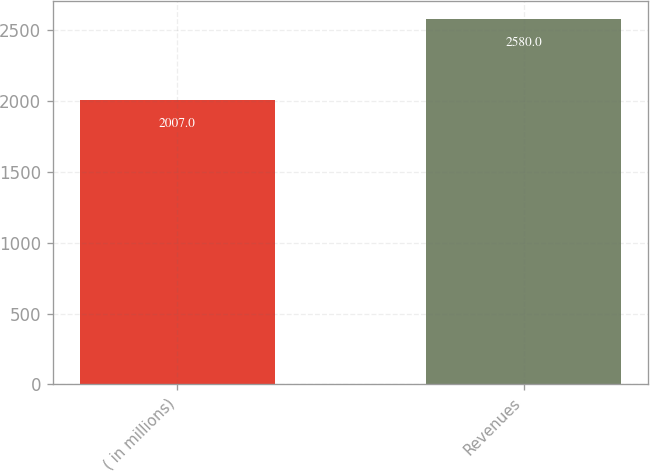Convert chart. <chart><loc_0><loc_0><loc_500><loc_500><bar_chart><fcel>( in millions)<fcel>Revenues<nl><fcel>2007<fcel>2580<nl></chart> 